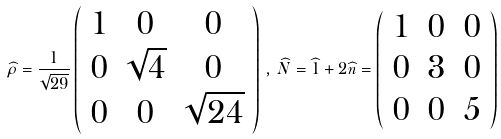<formula> <loc_0><loc_0><loc_500><loc_500>\widehat { \rho } = \frac { 1 } { \sqrt { 2 9 } } \left ( \begin{array} { c c c } 1 & 0 & 0 \\ 0 & \sqrt { 4 } & 0 \\ 0 & 0 & \sqrt { 2 4 } \end{array} \right ) \, , \, \widehat { N } = \widehat { 1 } + 2 \widehat { n } = \left ( \begin{array} { c c c } 1 & 0 & 0 \\ 0 & 3 & 0 \\ 0 & 0 & 5 \end{array} \right )</formula> 